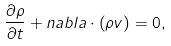<formula> <loc_0><loc_0><loc_500><loc_500>\frac { \partial \rho } { \partial t } + { n a b l a } \cdot \left ( \rho { v } \right ) = 0 ,</formula> 